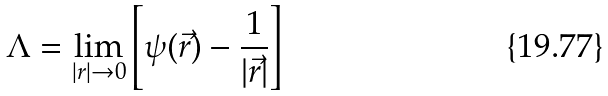Convert formula to latex. <formula><loc_0><loc_0><loc_500><loc_500>\Lambda = \lim _ { | r | \rightarrow 0 } \left [ \psi ( \vec { r } ) - \frac { 1 } { | \vec { r } | } \right ]</formula> 